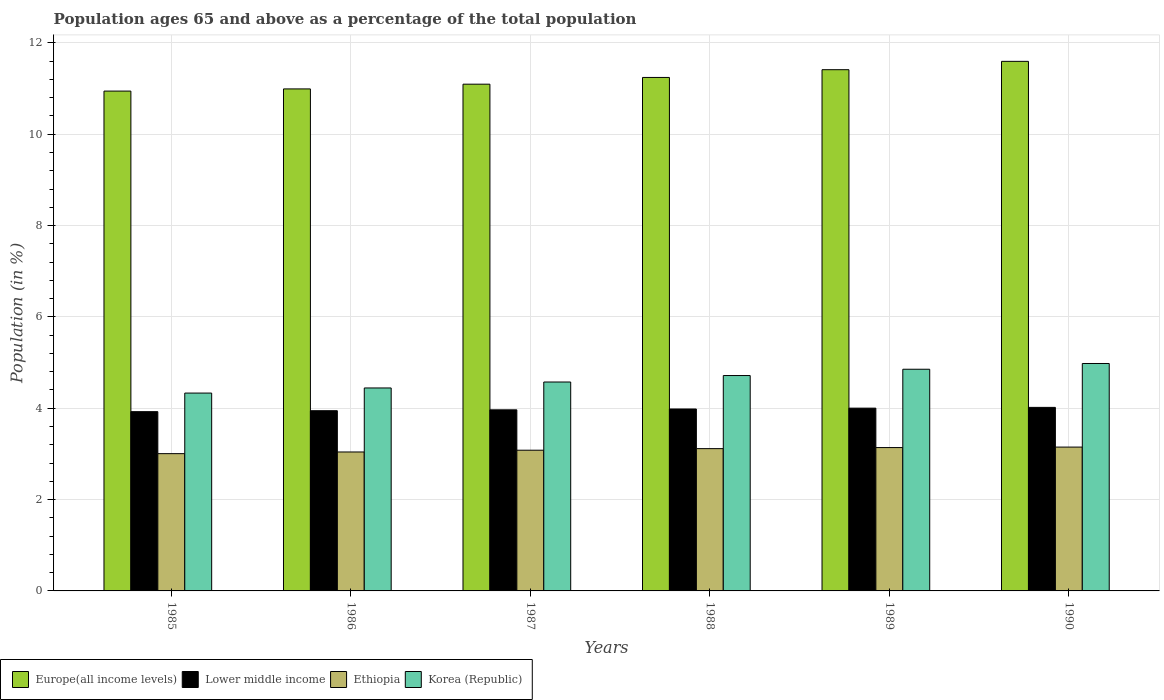How many different coloured bars are there?
Your answer should be very brief. 4. How many groups of bars are there?
Give a very brief answer. 6. Are the number of bars per tick equal to the number of legend labels?
Provide a succinct answer. Yes. Are the number of bars on each tick of the X-axis equal?
Provide a short and direct response. Yes. How many bars are there on the 1st tick from the left?
Provide a short and direct response. 4. How many bars are there on the 6th tick from the right?
Your response must be concise. 4. What is the percentage of the population ages 65 and above in Ethiopia in 1990?
Keep it short and to the point. 3.15. Across all years, what is the maximum percentage of the population ages 65 and above in Ethiopia?
Make the answer very short. 3.15. Across all years, what is the minimum percentage of the population ages 65 and above in Europe(all income levels)?
Give a very brief answer. 10.95. In which year was the percentage of the population ages 65 and above in Korea (Republic) maximum?
Make the answer very short. 1990. What is the total percentage of the population ages 65 and above in Korea (Republic) in the graph?
Your answer should be very brief. 27.9. What is the difference between the percentage of the population ages 65 and above in Korea (Republic) in 1985 and that in 1988?
Your response must be concise. -0.38. What is the difference between the percentage of the population ages 65 and above in Europe(all income levels) in 1985 and the percentage of the population ages 65 and above in Ethiopia in 1990?
Offer a very short reply. 7.8. What is the average percentage of the population ages 65 and above in Europe(all income levels) per year?
Your answer should be very brief. 11.21. In the year 1985, what is the difference between the percentage of the population ages 65 and above in Europe(all income levels) and percentage of the population ages 65 and above in Lower middle income?
Make the answer very short. 7.02. In how many years, is the percentage of the population ages 65 and above in Europe(all income levels) greater than 4.8?
Ensure brevity in your answer.  6. What is the ratio of the percentage of the population ages 65 and above in Ethiopia in 1987 to that in 1990?
Keep it short and to the point. 0.98. Is the percentage of the population ages 65 and above in Europe(all income levels) in 1986 less than that in 1990?
Offer a very short reply. Yes. What is the difference between the highest and the second highest percentage of the population ages 65 and above in Korea (Republic)?
Your answer should be compact. 0.13. What is the difference between the highest and the lowest percentage of the population ages 65 and above in Korea (Republic)?
Provide a short and direct response. 0.65. In how many years, is the percentage of the population ages 65 and above in Ethiopia greater than the average percentage of the population ages 65 and above in Ethiopia taken over all years?
Your response must be concise. 3. Is it the case that in every year, the sum of the percentage of the population ages 65 and above in Korea (Republic) and percentage of the population ages 65 and above in Ethiopia is greater than the sum of percentage of the population ages 65 and above in Lower middle income and percentage of the population ages 65 and above in Europe(all income levels)?
Your response must be concise. No. What does the 2nd bar from the left in 1988 represents?
Offer a very short reply. Lower middle income. What does the 1st bar from the right in 1988 represents?
Give a very brief answer. Korea (Republic). What is the difference between two consecutive major ticks on the Y-axis?
Ensure brevity in your answer.  2. Are the values on the major ticks of Y-axis written in scientific E-notation?
Your answer should be very brief. No. How are the legend labels stacked?
Provide a short and direct response. Horizontal. What is the title of the graph?
Your response must be concise. Population ages 65 and above as a percentage of the total population. Does "India" appear as one of the legend labels in the graph?
Your answer should be very brief. No. What is the Population (in %) of Europe(all income levels) in 1985?
Make the answer very short. 10.95. What is the Population (in %) of Lower middle income in 1985?
Offer a terse response. 3.93. What is the Population (in %) of Ethiopia in 1985?
Ensure brevity in your answer.  3.01. What is the Population (in %) in Korea (Republic) in 1985?
Make the answer very short. 4.33. What is the Population (in %) in Europe(all income levels) in 1986?
Provide a succinct answer. 10.99. What is the Population (in %) in Lower middle income in 1986?
Make the answer very short. 3.95. What is the Population (in %) of Ethiopia in 1986?
Make the answer very short. 3.04. What is the Population (in %) of Korea (Republic) in 1986?
Your answer should be very brief. 4.44. What is the Population (in %) in Europe(all income levels) in 1987?
Provide a short and direct response. 11.1. What is the Population (in %) of Lower middle income in 1987?
Give a very brief answer. 3.97. What is the Population (in %) of Ethiopia in 1987?
Your answer should be very brief. 3.08. What is the Population (in %) of Korea (Republic) in 1987?
Ensure brevity in your answer.  4.57. What is the Population (in %) in Europe(all income levels) in 1988?
Keep it short and to the point. 11.24. What is the Population (in %) of Lower middle income in 1988?
Make the answer very short. 3.98. What is the Population (in %) of Ethiopia in 1988?
Your answer should be compact. 3.12. What is the Population (in %) in Korea (Republic) in 1988?
Keep it short and to the point. 4.72. What is the Population (in %) in Europe(all income levels) in 1989?
Provide a succinct answer. 11.41. What is the Population (in %) of Lower middle income in 1989?
Give a very brief answer. 4. What is the Population (in %) of Ethiopia in 1989?
Your answer should be compact. 3.14. What is the Population (in %) of Korea (Republic) in 1989?
Give a very brief answer. 4.85. What is the Population (in %) of Europe(all income levels) in 1990?
Your answer should be compact. 11.6. What is the Population (in %) of Lower middle income in 1990?
Offer a terse response. 4.02. What is the Population (in %) of Ethiopia in 1990?
Provide a short and direct response. 3.15. What is the Population (in %) of Korea (Republic) in 1990?
Your answer should be compact. 4.98. Across all years, what is the maximum Population (in %) in Europe(all income levels)?
Offer a very short reply. 11.6. Across all years, what is the maximum Population (in %) in Lower middle income?
Your answer should be compact. 4.02. Across all years, what is the maximum Population (in %) in Ethiopia?
Offer a terse response. 3.15. Across all years, what is the maximum Population (in %) of Korea (Republic)?
Offer a terse response. 4.98. Across all years, what is the minimum Population (in %) in Europe(all income levels)?
Your response must be concise. 10.95. Across all years, what is the minimum Population (in %) in Lower middle income?
Provide a succinct answer. 3.93. Across all years, what is the minimum Population (in %) of Ethiopia?
Provide a short and direct response. 3.01. Across all years, what is the minimum Population (in %) of Korea (Republic)?
Ensure brevity in your answer.  4.33. What is the total Population (in %) in Europe(all income levels) in the graph?
Your answer should be very brief. 67.29. What is the total Population (in %) of Lower middle income in the graph?
Make the answer very short. 23.84. What is the total Population (in %) in Ethiopia in the graph?
Provide a succinct answer. 18.53. What is the total Population (in %) in Korea (Republic) in the graph?
Offer a terse response. 27.9. What is the difference between the Population (in %) in Europe(all income levels) in 1985 and that in 1986?
Provide a succinct answer. -0.05. What is the difference between the Population (in %) of Lower middle income in 1985 and that in 1986?
Give a very brief answer. -0.02. What is the difference between the Population (in %) of Ethiopia in 1985 and that in 1986?
Offer a very short reply. -0.04. What is the difference between the Population (in %) of Korea (Republic) in 1985 and that in 1986?
Provide a succinct answer. -0.11. What is the difference between the Population (in %) of Europe(all income levels) in 1985 and that in 1987?
Ensure brevity in your answer.  -0.15. What is the difference between the Population (in %) of Lower middle income in 1985 and that in 1987?
Provide a short and direct response. -0.04. What is the difference between the Population (in %) in Ethiopia in 1985 and that in 1987?
Offer a terse response. -0.08. What is the difference between the Population (in %) of Korea (Republic) in 1985 and that in 1987?
Provide a short and direct response. -0.24. What is the difference between the Population (in %) of Europe(all income levels) in 1985 and that in 1988?
Make the answer very short. -0.3. What is the difference between the Population (in %) of Lower middle income in 1985 and that in 1988?
Offer a terse response. -0.06. What is the difference between the Population (in %) of Ethiopia in 1985 and that in 1988?
Provide a succinct answer. -0.11. What is the difference between the Population (in %) in Korea (Republic) in 1985 and that in 1988?
Ensure brevity in your answer.  -0.38. What is the difference between the Population (in %) of Europe(all income levels) in 1985 and that in 1989?
Your answer should be very brief. -0.47. What is the difference between the Population (in %) of Lower middle income in 1985 and that in 1989?
Give a very brief answer. -0.08. What is the difference between the Population (in %) of Ethiopia in 1985 and that in 1989?
Provide a succinct answer. -0.13. What is the difference between the Population (in %) of Korea (Republic) in 1985 and that in 1989?
Provide a short and direct response. -0.52. What is the difference between the Population (in %) in Europe(all income levels) in 1985 and that in 1990?
Your answer should be compact. -0.65. What is the difference between the Population (in %) in Lower middle income in 1985 and that in 1990?
Offer a very short reply. -0.09. What is the difference between the Population (in %) in Ethiopia in 1985 and that in 1990?
Make the answer very short. -0.14. What is the difference between the Population (in %) of Korea (Republic) in 1985 and that in 1990?
Make the answer very short. -0.65. What is the difference between the Population (in %) in Europe(all income levels) in 1986 and that in 1987?
Provide a succinct answer. -0.1. What is the difference between the Population (in %) in Lower middle income in 1986 and that in 1987?
Keep it short and to the point. -0.02. What is the difference between the Population (in %) in Ethiopia in 1986 and that in 1987?
Provide a short and direct response. -0.04. What is the difference between the Population (in %) of Korea (Republic) in 1986 and that in 1987?
Ensure brevity in your answer.  -0.13. What is the difference between the Population (in %) of Europe(all income levels) in 1986 and that in 1988?
Your response must be concise. -0.25. What is the difference between the Population (in %) of Lower middle income in 1986 and that in 1988?
Keep it short and to the point. -0.04. What is the difference between the Population (in %) of Ethiopia in 1986 and that in 1988?
Keep it short and to the point. -0.07. What is the difference between the Population (in %) in Korea (Republic) in 1986 and that in 1988?
Provide a short and direct response. -0.27. What is the difference between the Population (in %) in Europe(all income levels) in 1986 and that in 1989?
Give a very brief answer. -0.42. What is the difference between the Population (in %) in Lower middle income in 1986 and that in 1989?
Make the answer very short. -0.06. What is the difference between the Population (in %) of Ethiopia in 1986 and that in 1989?
Offer a very short reply. -0.1. What is the difference between the Population (in %) of Korea (Republic) in 1986 and that in 1989?
Give a very brief answer. -0.41. What is the difference between the Population (in %) in Europe(all income levels) in 1986 and that in 1990?
Offer a terse response. -0.6. What is the difference between the Population (in %) in Lower middle income in 1986 and that in 1990?
Offer a terse response. -0.07. What is the difference between the Population (in %) of Ethiopia in 1986 and that in 1990?
Keep it short and to the point. -0.11. What is the difference between the Population (in %) in Korea (Republic) in 1986 and that in 1990?
Your response must be concise. -0.54. What is the difference between the Population (in %) in Europe(all income levels) in 1987 and that in 1988?
Offer a terse response. -0.15. What is the difference between the Population (in %) of Lower middle income in 1987 and that in 1988?
Ensure brevity in your answer.  -0.02. What is the difference between the Population (in %) of Ethiopia in 1987 and that in 1988?
Offer a terse response. -0.03. What is the difference between the Population (in %) in Korea (Republic) in 1987 and that in 1988?
Ensure brevity in your answer.  -0.14. What is the difference between the Population (in %) of Europe(all income levels) in 1987 and that in 1989?
Offer a very short reply. -0.32. What is the difference between the Population (in %) in Lower middle income in 1987 and that in 1989?
Ensure brevity in your answer.  -0.04. What is the difference between the Population (in %) in Ethiopia in 1987 and that in 1989?
Give a very brief answer. -0.06. What is the difference between the Population (in %) in Korea (Republic) in 1987 and that in 1989?
Ensure brevity in your answer.  -0.28. What is the difference between the Population (in %) of Europe(all income levels) in 1987 and that in 1990?
Your response must be concise. -0.5. What is the difference between the Population (in %) in Lower middle income in 1987 and that in 1990?
Your answer should be compact. -0.05. What is the difference between the Population (in %) of Ethiopia in 1987 and that in 1990?
Your answer should be compact. -0.07. What is the difference between the Population (in %) of Korea (Republic) in 1987 and that in 1990?
Offer a very short reply. -0.41. What is the difference between the Population (in %) in Europe(all income levels) in 1988 and that in 1989?
Ensure brevity in your answer.  -0.17. What is the difference between the Population (in %) of Lower middle income in 1988 and that in 1989?
Provide a succinct answer. -0.02. What is the difference between the Population (in %) of Ethiopia in 1988 and that in 1989?
Your answer should be compact. -0.02. What is the difference between the Population (in %) in Korea (Republic) in 1988 and that in 1989?
Offer a terse response. -0.14. What is the difference between the Population (in %) of Europe(all income levels) in 1988 and that in 1990?
Provide a succinct answer. -0.35. What is the difference between the Population (in %) of Lower middle income in 1988 and that in 1990?
Offer a terse response. -0.04. What is the difference between the Population (in %) of Ethiopia in 1988 and that in 1990?
Offer a very short reply. -0.03. What is the difference between the Population (in %) of Korea (Republic) in 1988 and that in 1990?
Your answer should be very brief. -0.26. What is the difference between the Population (in %) of Europe(all income levels) in 1989 and that in 1990?
Your answer should be compact. -0.18. What is the difference between the Population (in %) in Lower middle income in 1989 and that in 1990?
Your answer should be very brief. -0.02. What is the difference between the Population (in %) in Ethiopia in 1989 and that in 1990?
Give a very brief answer. -0.01. What is the difference between the Population (in %) of Korea (Republic) in 1989 and that in 1990?
Ensure brevity in your answer.  -0.13. What is the difference between the Population (in %) of Europe(all income levels) in 1985 and the Population (in %) of Lower middle income in 1986?
Your response must be concise. 7. What is the difference between the Population (in %) in Europe(all income levels) in 1985 and the Population (in %) in Ethiopia in 1986?
Your answer should be compact. 7.9. What is the difference between the Population (in %) in Europe(all income levels) in 1985 and the Population (in %) in Korea (Republic) in 1986?
Provide a succinct answer. 6.5. What is the difference between the Population (in %) in Lower middle income in 1985 and the Population (in %) in Ethiopia in 1986?
Offer a very short reply. 0.88. What is the difference between the Population (in %) of Lower middle income in 1985 and the Population (in %) of Korea (Republic) in 1986?
Your response must be concise. -0.52. What is the difference between the Population (in %) of Ethiopia in 1985 and the Population (in %) of Korea (Republic) in 1986?
Ensure brevity in your answer.  -1.44. What is the difference between the Population (in %) in Europe(all income levels) in 1985 and the Population (in %) in Lower middle income in 1987?
Keep it short and to the point. 6.98. What is the difference between the Population (in %) in Europe(all income levels) in 1985 and the Population (in %) in Ethiopia in 1987?
Provide a short and direct response. 7.86. What is the difference between the Population (in %) of Europe(all income levels) in 1985 and the Population (in %) of Korea (Republic) in 1987?
Make the answer very short. 6.37. What is the difference between the Population (in %) in Lower middle income in 1985 and the Population (in %) in Ethiopia in 1987?
Ensure brevity in your answer.  0.84. What is the difference between the Population (in %) in Lower middle income in 1985 and the Population (in %) in Korea (Republic) in 1987?
Your answer should be very brief. -0.65. What is the difference between the Population (in %) of Ethiopia in 1985 and the Population (in %) of Korea (Republic) in 1987?
Offer a very short reply. -1.57. What is the difference between the Population (in %) of Europe(all income levels) in 1985 and the Population (in %) of Lower middle income in 1988?
Your answer should be compact. 6.96. What is the difference between the Population (in %) of Europe(all income levels) in 1985 and the Population (in %) of Ethiopia in 1988?
Offer a very short reply. 7.83. What is the difference between the Population (in %) in Europe(all income levels) in 1985 and the Population (in %) in Korea (Republic) in 1988?
Keep it short and to the point. 6.23. What is the difference between the Population (in %) in Lower middle income in 1985 and the Population (in %) in Ethiopia in 1988?
Your answer should be compact. 0.81. What is the difference between the Population (in %) of Lower middle income in 1985 and the Population (in %) of Korea (Republic) in 1988?
Your response must be concise. -0.79. What is the difference between the Population (in %) of Ethiopia in 1985 and the Population (in %) of Korea (Republic) in 1988?
Provide a succinct answer. -1.71. What is the difference between the Population (in %) in Europe(all income levels) in 1985 and the Population (in %) in Lower middle income in 1989?
Your response must be concise. 6.94. What is the difference between the Population (in %) of Europe(all income levels) in 1985 and the Population (in %) of Ethiopia in 1989?
Make the answer very short. 7.81. What is the difference between the Population (in %) of Europe(all income levels) in 1985 and the Population (in %) of Korea (Republic) in 1989?
Provide a short and direct response. 6.09. What is the difference between the Population (in %) in Lower middle income in 1985 and the Population (in %) in Ethiopia in 1989?
Keep it short and to the point. 0.79. What is the difference between the Population (in %) in Lower middle income in 1985 and the Population (in %) in Korea (Republic) in 1989?
Offer a terse response. -0.93. What is the difference between the Population (in %) in Ethiopia in 1985 and the Population (in %) in Korea (Republic) in 1989?
Offer a very short reply. -1.85. What is the difference between the Population (in %) in Europe(all income levels) in 1985 and the Population (in %) in Lower middle income in 1990?
Your answer should be compact. 6.93. What is the difference between the Population (in %) of Europe(all income levels) in 1985 and the Population (in %) of Ethiopia in 1990?
Keep it short and to the point. 7.8. What is the difference between the Population (in %) in Europe(all income levels) in 1985 and the Population (in %) in Korea (Republic) in 1990?
Your answer should be very brief. 5.97. What is the difference between the Population (in %) of Lower middle income in 1985 and the Population (in %) of Ethiopia in 1990?
Ensure brevity in your answer.  0.78. What is the difference between the Population (in %) in Lower middle income in 1985 and the Population (in %) in Korea (Republic) in 1990?
Offer a very short reply. -1.05. What is the difference between the Population (in %) in Ethiopia in 1985 and the Population (in %) in Korea (Republic) in 1990?
Your response must be concise. -1.97. What is the difference between the Population (in %) of Europe(all income levels) in 1986 and the Population (in %) of Lower middle income in 1987?
Give a very brief answer. 7.03. What is the difference between the Population (in %) in Europe(all income levels) in 1986 and the Population (in %) in Ethiopia in 1987?
Offer a terse response. 7.91. What is the difference between the Population (in %) in Europe(all income levels) in 1986 and the Population (in %) in Korea (Republic) in 1987?
Give a very brief answer. 6.42. What is the difference between the Population (in %) in Lower middle income in 1986 and the Population (in %) in Ethiopia in 1987?
Provide a succinct answer. 0.86. What is the difference between the Population (in %) of Lower middle income in 1986 and the Population (in %) of Korea (Republic) in 1987?
Make the answer very short. -0.63. What is the difference between the Population (in %) of Ethiopia in 1986 and the Population (in %) of Korea (Republic) in 1987?
Provide a short and direct response. -1.53. What is the difference between the Population (in %) in Europe(all income levels) in 1986 and the Population (in %) in Lower middle income in 1988?
Ensure brevity in your answer.  7.01. What is the difference between the Population (in %) of Europe(all income levels) in 1986 and the Population (in %) of Ethiopia in 1988?
Provide a succinct answer. 7.88. What is the difference between the Population (in %) in Europe(all income levels) in 1986 and the Population (in %) in Korea (Republic) in 1988?
Provide a succinct answer. 6.28. What is the difference between the Population (in %) in Lower middle income in 1986 and the Population (in %) in Ethiopia in 1988?
Give a very brief answer. 0.83. What is the difference between the Population (in %) of Lower middle income in 1986 and the Population (in %) of Korea (Republic) in 1988?
Keep it short and to the point. -0.77. What is the difference between the Population (in %) of Ethiopia in 1986 and the Population (in %) of Korea (Republic) in 1988?
Your answer should be compact. -1.67. What is the difference between the Population (in %) in Europe(all income levels) in 1986 and the Population (in %) in Lower middle income in 1989?
Give a very brief answer. 6.99. What is the difference between the Population (in %) of Europe(all income levels) in 1986 and the Population (in %) of Ethiopia in 1989?
Keep it short and to the point. 7.85. What is the difference between the Population (in %) of Europe(all income levels) in 1986 and the Population (in %) of Korea (Republic) in 1989?
Provide a succinct answer. 6.14. What is the difference between the Population (in %) in Lower middle income in 1986 and the Population (in %) in Ethiopia in 1989?
Provide a succinct answer. 0.81. What is the difference between the Population (in %) of Lower middle income in 1986 and the Population (in %) of Korea (Republic) in 1989?
Make the answer very short. -0.91. What is the difference between the Population (in %) in Ethiopia in 1986 and the Population (in %) in Korea (Republic) in 1989?
Provide a succinct answer. -1.81. What is the difference between the Population (in %) in Europe(all income levels) in 1986 and the Population (in %) in Lower middle income in 1990?
Ensure brevity in your answer.  6.97. What is the difference between the Population (in %) of Europe(all income levels) in 1986 and the Population (in %) of Ethiopia in 1990?
Make the answer very short. 7.84. What is the difference between the Population (in %) in Europe(all income levels) in 1986 and the Population (in %) in Korea (Republic) in 1990?
Give a very brief answer. 6.01. What is the difference between the Population (in %) of Lower middle income in 1986 and the Population (in %) of Ethiopia in 1990?
Ensure brevity in your answer.  0.8. What is the difference between the Population (in %) in Lower middle income in 1986 and the Population (in %) in Korea (Republic) in 1990?
Ensure brevity in your answer.  -1.03. What is the difference between the Population (in %) of Ethiopia in 1986 and the Population (in %) of Korea (Republic) in 1990?
Your answer should be very brief. -1.94. What is the difference between the Population (in %) in Europe(all income levels) in 1987 and the Population (in %) in Lower middle income in 1988?
Give a very brief answer. 7.11. What is the difference between the Population (in %) of Europe(all income levels) in 1987 and the Population (in %) of Ethiopia in 1988?
Offer a terse response. 7.98. What is the difference between the Population (in %) in Europe(all income levels) in 1987 and the Population (in %) in Korea (Republic) in 1988?
Your answer should be very brief. 6.38. What is the difference between the Population (in %) of Lower middle income in 1987 and the Population (in %) of Ethiopia in 1988?
Keep it short and to the point. 0.85. What is the difference between the Population (in %) in Lower middle income in 1987 and the Population (in %) in Korea (Republic) in 1988?
Offer a terse response. -0.75. What is the difference between the Population (in %) in Ethiopia in 1987 and the Population (in %) in Korea (Republic) in 1988?
Provide a succinct answer. -1.64. What is the difference between the Population (in %) in Europe(all income levels) in 1987 and the Population (in %) in Lower middle income in 1989?
Provide a succinct answer. 7.09. What is the difference between the Population (in %) in Europe(all income levels) in 1987 and the Population (in %) in Ethiopia in 1989?
Provide a short and direct response. 7.96. What is the difference between the Population (in %) of Europe(all income levels) in 1987 and the Population (in %) of Korea (Republic) in 1989?
Ensure brevity in your answer.  6.24. What is the difference between the Population (in %) in Lower middle income in 1987 and the Population (in %) in Ethiopia in 1989?
Ensure brevity in your answer.  0.83. What is the difference between the Population (in %) of Lower middle income in 1987 and the Population (in %) of Korea (Republic) in 1989?
Give a very brief answer. -0.89. What is the difference between the Population (in %) of Ethiopia in 1987 and the Population (in %) of Korea (Republic) in 1989?
Your response must be concise. -1.77. What is the difference between the Population (in %) of Europe(all income levels) in 1987 and the Population (in %) of Lower middle income in 1990?
Make the answer very short. 7.08. What is the difference between the Population (in %) in Europe(all income levels) in 1987 and the Population (in %) in Ethiopia in 1990?
Ensure brevity in your answer.  7.95. What is the difference between the Population (in %) of Europe(all income levels) in 1987 and the Population (in %) of Korea (Republic) in 1990?
Your answer should be compact. 6.12. What is the difference between the Population (in %) of Lower middle income in 1987 and the Population (in %) of Ethiopia in 1990?
Provide a short and direct response. 0.82. What is the difference between the Population (in %) of Lower middle income in 1987 and the Population (in %) of Korea (Republic) in 1990?
Your answer should be very brief. -1.01. What is the difference between the Population (in %) of Ethiopia in 1987 and the Population (in %) of Korea (Republic) in 1990?
Provide a short and direct response. -1.9. What is the difference between the Population (in %) in Europe(all income levels) in 1988 and the Population (in %) in Lower middle income in 1989?
Provide a succinct answer. 7.24. What is the difference between the Population (in %) of Europe(all income levels) in 1988 and the Population (in %) of Ethiopia in 1989?
Your answer should be compact. 8.1. What is the difference between the Population (in %) of Europe(all income levels) in 1988 and the Population (in %) of Korea (Republic) in 1989?
Your answer should be very brief. 6.39. What is the difference between the Population (in %) in Lower middle income in 1988 and the Population (in %) in Ethiopia in 1989?
Your response must be concise. 0.84. What is the difference between the Population (in %) of Lower middle income in 1988 and the Population (in %) of Korea (Republic) in 1989?
Provide a succinct answer. -0.87. What is the difference between the Population (in %) of Ethiopia in 1988 and the Population (in %) of Korea (Republic) in 1989?
Ensure brevity in your answer.  -1.74. What is the difference between the Population (in %) in Europe(all income levels) in 1988 and the Population (in %) in Lower middle income in 1990?
Your answer should be very brief. 7.22. What is the difference between the Population (in %) in Europe(all income levels) in 1988 and the Population (in %) in Ethiopia in 1990?
Your answer should be compact. 8.09. What is the difference between the Population (in %) in Europe(all income levels) in 1988 and the Population (in %) in Korea (Republic) in 1990?
Provide a short and direct response. 6.26. What is the difference between the Population (in %) in Lower middle income in 1988 and the Population (in %) in Ethiopia in 1990?
Your response must be concise. 0.83. What is the difference between the Population (in %) of Lower middle income in 1988 and the Population (in %) of Korea (Republic) in 1990?
Your answer should be very brief. -1. What is the difference between the Population (in %) of Ethiopia in 1988 and the Population (in %) of Korea (Republic) in 1990?
Offer a very short reply. -1.86. What is the difference between the Population (in %) in Europe(all income levels) in 1989 and the Population (in %) in Lower middle income in 1990?
Provide a succinct answer. 7.39. What is the difference between the Population (in %) of Europe(all income levels) in 1989 and the Population (in %) of Ethiopia in 1990?
Give a very brief answer. 8.26. What is the difference between the Population (in %) in Europe(all income levels) in 1989 and the Population (in %) in Korea (Republic) in 1990?
Make the answer very short. 6.43. What is the difference between the Population (in %) of Lower middle income in 1989 and the Population (in %) of Ethiopia in 1990?
Offer a very short reply. 0.85. What is the difference between the Population (in %) in Lower middle income in 1989 and the Population (in %) in Korea (Republic) in 1990?
Provide a succinct answer. -0.98. What is the difference between the Population (in %) of Ethiopia in 1989 and the Population (in %) of Korea (Republic) in 1990?
Offer a very short reply. -1.84. What is the average Population (in %) of Europe(all income levels) per year?
Keep it short and to the point. 11.21. What is the average Population (in %) in Lower middle income per year?
Provide a short and direct response. 3.97. What is the average Population (in %) in Ethiopia per year?
Provide a short and direct response. 3.09. What is the average Population (in %) in Korea (Republic) per year?
Provide a short and direct response. 4.65. In the year 1985, what is the difference between the Population (in %) of Europe(all income levels) and Population (in %) of Lower middle income?
Provide a succinct answer. 7.02. In the year 1985, what is the difference between the Population (in %) of Europe(all income levels) and Population (in %) of Ethiopia?
Ensure brevity in your answer.  7.94. In the year 1985, what is the difference between the Population (in %) of Europe(all income levels) and Population (in %) of Korea (Republic)?
Provide a succinct answer. 6.61. In the year 1985, what is the difference between the Population (in %) of Lower middle income and Population (in %) of Ethiopia?
Provide a succinct answer. 0.92. In the year 1985, what is the difference between the Population (in %) in Lower middle income and Population (in %) in Korea (Republic)?
Provide a succinct answer. -0.41. In the year 1985, what is the difference between the Population (in %) in Ethiopia and Population (in %) in Korea (Republic)?
Ensure brevity in your answer.  -1.33. In the year 1986, what is the difference between the Population (in %) of Europe(all income levels) and Population (in %) of Lower middle income?
Give a very brief answer. 7.05. In the year 1986, what is the difference between the Population (in %) in Europe(all income levels) and Population (in %) in Ethiopia?
Provide a short and direct response. 7.95. In the year 1986, what is the difference between the Population (in %) of Europe(all income levels) and Population (in %) of Korea (Republic)?
Your answer should be very brief. 6.55. In the year 1986, what is the difference between the Population (in %) in Lower middle income and Population (in %) in Ethiopia?
Your answer should be very brief. 0.9. In the year 1986, what is the difference between the Population (in %) of Lower middle income and Population (in %) of Korea (Republic)?
Ensure brevity in your answer.  -0.5. In the year 1986, what is the difference between the Population (in %) of Ethiopia and Population (in %) of Korea (Republic)?
Your answer should be very brief. -1.4. In the year 1987, what is the difference between the Population (in %) in Europe(all income levels) and Population (in %) in Lower middle income?
Your answer should be very brief. 7.13. In the year 1987, what is the difference between the Population (in %) of Europe(all income levels) and Population (in %) of Ethiopia?
Your response must be concise. 8.02. In the year 1987, what is the difference between the Population (in %) in Europe(all income levels) and Population (in %) in Korea (Republic)?
Your response must be concise. 6.52. In the year 1987, what is the difference between the Population (in %) in Lower middle income and Population (in %) in Ethiopia?
Your answer should be very brief. 0.88. In the year 1987, what is the difference between the Population (in %) of Lower middle income and Population (in %) of Korea (Republic)?
Your answer should be compact. -0.61. In the year 1987, what is the difference between the Population (in %) of Ethiopia and Population (in %) of Korea (Republic)?
Make the answer very short. -1.49. In the year 1988, what is the difference between the Population (in %) of Europe(all income levels) and Population (in %) of Lower middle income?
Your answer should be very brief. 7.26. In the year 1988, what is the difference between the Population (in %) in Europe(all income levels) and Population (in %) in Ethiopia?
Ensure brevity in your answer.  8.13. In the year 1988, what is the difference between the Population (in %) of Europe(all income levels) and Population (in %) of Korea (Republic)?
Offer a very short reply. 6.53. In the year 1988, what is the difference between the Population (in %) of Lower middle income and Population (in %) of Ethiopia?
Offer a terse response. 0.87. In the year 1988, what is the difference between the Population (in %) in Lower middle income and Population (in %) in Korea (Republic)?
Offer a terse response. -0.73. In the year 1988, what is the difference between the Population (in %) in Ethiopia and Population (in %) in Korea (Republic)?
Ensure brevity in your answer.  -1.6. In the year 1989, what is the difference between the Population (in %) of Europe(all income levels) and Population (in %) of Lower middle income?
Your answer should be very brief. 7.41. In the year 1989, what is the difference between the Population (in %) of Europe(all income levels) and Population (in %) of Ethiopia?
Provide a succinct answer. 8.27. In the year 1989, what is the difference between the Population (in %) of Europe(all income levels) and Population (in %) of Korea (Republic)?
Your response must be concise. 6.56. In the year 1989, what is the difference between the Population (in %) in Lower middle income and Population (in %) in Ethiopia?
Offer a terse response. 0.86. In the year 1989, what is the difference between the Population (in %) of Lower middle income and Population (in %) of Korea (Republic)?
Provide a short and direct response. -0.85. In the year 1989, what is the difference between the Population (in %) in Ethiopia and Population (in %) in Korea (Republic)?
Offer a very short reply. -1.72. In the year 1990, what is the difference between the Population (in %) of Europe(all income levels) and Population (in %) of Lower middle income?
Provide a succinct answer. 7.58. In the year 1990, what is the difference between the Population (in %) of Europe(all income levels) and Population (in %) of Ethiopia?
Make the answer very short. 8.45. In the year 1990, what is the difference between the Population (in %) in Europe(all income levels) and Population (in %) in Korea (Republic)?
Keep it short and to the point. 6.62. In the year 1990, what is the difference between the Population (in %) of Lower middle income and Population (in %) of Ethiopia?
Provide a succinct answer. 0.87. In the year 1990, what is the difference between the Population (in %) in Lower middle income and Population (in %) in Korea (Republic)?
Keep it short and to the point. -0.96. In the year 1990, what is the difference between the Population (in %) of Ethiopia and Population (in %) of Korea (Republic)?
Offer a very short reply. -1.83. What is the ratio of the Population (in %) of Europe(all income levels) in 1985 to that in 1986?
Your response must be concise. 1. What is the ratio of the Population (in %) in Ethiopia in 1985 to that in 1986?
Give a very brief answer. 0.99. What is the ratio of the Population (in %) in Korea (Republic) in 1985 to that in 1986?
Offer a very short reply. 0.97. What is the ratio of the Population (in %) of Europe(all income levels) in 1985 to that in 1987?
Offer a terse response. 0.99. What is the ratio of the Population (in %) in Lower middle income in 1985 to that in 1987?
Provide a succinct answer. 0.99. What is the ratio of the Population (in %) of Ethiopia in 1985 to that in 1987?
Your answer should be compact. 0.98. What is the ratio of the Population (in %) of Korea (Republic) in 1985 to that in 1987?
Your answer should be very brief. 0.95. What is the ratio of the Population (in %) of Europe(all income levels) in 1985 to that in 1988?
Your answer should be compact. 0.97. What is the ratio of the Population (in %) in Ethiopia in 1985 to that in 1988?
Offer a very short reply. 0.96. What is the ratio of the Population (in %) of Korea (Republic) in 1985 to that in 1988?
Your answer should be very brief. 0.92. What is the ratio of the Population (in %) in Europe(all income levels) in 1985 to that in 1989?
Your answer should be very brief. 0.96. What is the ratio of the Population (in %) of Lower middle income in 1985 to that in 1989?
Your answer should be compact. 0.98. What is the ratio of the Population (in %) in Ethiopia in 1985 to that in 1989?
Your answer should be compact. 0.96. What is the ratio of the Population (in %) of Korea (Republic) in 1985 to that in 1989?
Your answer should be compact. 0.89. What is the ratio of the Population (in %) of Europe(all income levels) in 1985 to that in 1990?
Provide a succinct answer. 0.94. What is the ratio of the Population (in %) of Lower middle income in 1985 to that in 1990?
Ensure brevity in your answer.  0.98. What is the ratio of the Population (in %) in Ethiopia in 1985 to that in 1990?
Offer a terse response. 0.95. What is the ratio of the Population (in %) in Korea (Republic) in 1985 to that in 1990?
Your answer should be very brief. 0.87. What is the ratio of the Population (in %) of Europe(all income levels) in 1986 to that in 1987?
Keep it short and to the point. 0.99. What is the ratio of the Population (in %) of Lower middle income in 1986 to that in 1987?
Ensure brevity in your answer.  1. What is the ratio of the Population (in %) in Ethiopia in 1986 to that in 1987?
Provide a short and direct response. 0.99. What is the ratio of the Population (in %) in Korea (Republic) in 1986 to that in 1987?
Offer a very short reply. 0.97. What is the ratio of the Population (in %) of Europe(all income levels) in 1986 to that in 1988?
Provide a short and direct response. 0.98. What is the ratio of the Population (in %) in Lower middle income in 1986 to that in 1988?
Your answer should be very brief. 0.99. What is the ratio of the Population (in %) in Ethiopia in 1986 to that in 1988?
Offer a terse response. 0.98. What is the ratio of the Population (in %) in Korea (Republic) in 1986 to that in 1988?
Keep it short and to the point. 0.94. What is the ratio of the Population (in %) of Europe(all income levels) in 1986 to that in 1989?
Provide a short and direct response. 0.96. What is the ratio of the Population (in %) in Lower middle income in 1986 to that in 1989?
Keep it short and to the point. 0.99. What is the ratio of the Population (in %) in Ethiopia in 1986 to that in 1989?
Your answer should be very brief. 0.97. What is the ratio of the Population (in %) in Korea (Republic) in 1986 to that in 1989?
Your response must be concise. 0.92. What is the ratio of the Population (in %) of Europe(all income levels) in 1986 to that in 1990?
Give a very brief answer. 0.95. What is the ratio of the Population (in %) in Lower middle income in 1986 to that in 1990?
Offer a very short reply. 0.98. What is the ratio of the Population (in %) in Korea (Republic) in 1986 to that in 1990?
Give a very brief answer. 0.89. What is the ratio of the Population (in %) in Europe(all income levels) in 1987 to that in 1988?
Give a very brief answer. 0.99. What is the ratio of the Population (in %) of Lower middle income in 1987 to that in 1988?
Offer a terse response. 1. What is the ratio of the Population (in %) in Europe(all income levels) in 1987 to that in 1989?
Keep it short and to the point. 0.97. What is the ratio of the Population (in %) in Lower middle income in 1987 to that in 1989?
Your response must be concise. 0.99. What is the ratio of the Population (in %) in Ethiopia in 1987 to that in 1989?
Ensure brevity in your answer.  0.98. What is the ratio of the Population (in %) in Korea (Republic) in 1987 to that in 1989?
Make the answer very short. 0.94. What is the ratio of the Population (in %) in Europe(all income levels) in 1987 to that in 1990?
Provide a succinct answer. 0.96. What is the ratio of the Population (in %) of Lower middle income in 1987 to that in 1990?
Ensure brevity in your answer.  0.99. What is the ratio of the Population (in %) of Ethiopia in 1987 to that in 1990?
Provide a succinct answer. 0.98. What is the ratio of the Population (in %) of Korea (Republic) in 1987 to that in 1990?
Offer a terse response. 0.92. What is the ratio of the Population (in %) of Europe(all income levels) in 1988 to that in 1989?
Ensure brevity in your answer.  0.99. What is the ratio of the Population (in %) in Ethiopia in 1988 to that in 1989?
Ensure brevity in your answer.  0.99. What is the ratio of the Population (in %) in Korea (Republic) in 1988 to that in 1989?
Provide a succinct answer. 0.97. What is the ratio of the Population (in %) of Europe(all income levels) in 1988 to that in 1990?
Ensure brevity in your answer.  0.97. What is the ratio of the Population (in %) in Lower middle income in 1988 to that in 1990?
Offer a very short reply. 0.99. What is the ratio of the Population (in %) of Ethiopia in 1988 to that in 1990?
Ensure brevity in your answer.  0.99. What is the ratio of the Population (in %) in Korea (Republic) in 1988 to that in 1990?
Your answer should be compact. 0.95. What is the ratio of the Population (in %) of Europe(all income levels) in 1989 to that in 1990?
Make the answer very short. 0.98. What is the ratio of the Population (in %) in Lower middle income in 1989 to that in 1990?
Give a very brief answer. 1. What is the ratio of the Population (in %) in Korea (Republic) in 1989 to that in 1990?
Offer a terse response. 0.97. What is the difference between the highest and the second highest Population (in %) of Europe(all income levels)?
Offer a very short reply. 0.18. What is the difference between the highest and the second highest Population (in %) of Lower middle income?
Your answer should be compact. 0.02. What is the difference between the highest and the second highest Population (in %) of Ethiopia?
Offer a very short reply. 0.01. What is the difference between the highest and the second highest Population (in %) in Korea (Republic)?
Provide a succinct answer. 0.13. What is the difference between the highest and the lowest Population (in %) of Europe(all income levels)?
Your answer should be compact. 0.65. What is the difference between the highest and the lowest Population (in %) in Lower middle income?
Offer a very short reply. 0.09. What is the difference between the highest and the lowest Population (in %) in Ethiopia?
Provide a short and direct response. 0.14. What is the difference between the highest and the lowest Population (in %) of Korea (Republic)?
Offer a terse response. 0.65. 